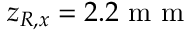<formula> <loc_0><loc_0><loc_500><loc_500>z _ { R , x } = 2 . 2 m m</formula> 